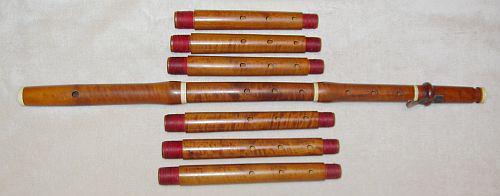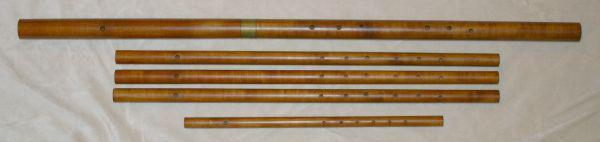The first image is the image on the left, the second image is the image on the right. For the images shown, is this caption "The flutes in one of the images are arranged with top to bottom from smallest to largest." true? Answer yes or no. No. 